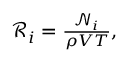Convert formula to latex. <formula><loc_0><loc_0><loc_500><loc_500>\begin{array} { r } { \mathcal { R } _ { i } = \frac { \mathcal { N } _ { i } } { \rho V T } , } \end{array}</formula> 